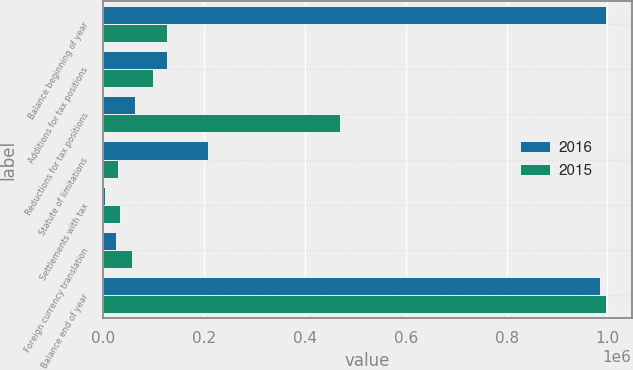Convert chart. <chart><loc_0><loc_0><loc_500><loc_500><stacked_bar_chart><ecel><fcel>Balance beginning of year<fcel>Additions for tax positions<fcel>Reductions for tax positions<fcel>Statute of limitations<fcel>Settlements with tax<fcel>Foreign currency translation<fcel>Balance end of year<nl><fcel>2016<fcel>997935<fcel>126353<fcel>63782<fcel>208295<fcel>3703<fcel>25850<fcel>985755<nl><fcel>2015<fcel>126353<fcel>97694<fcel>470147<fcel>28116<fcel>33743<fcel>56996<fcel>997935<nl></chart> 